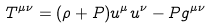Convert formula to latex. <formula><loc_0><loc_0><loc_500><loc_500>T ^ { \mu \nu } = ( \rho + P ) u ^ { \mu } u ^ { \nu } - P g ^ { \mu \nu }</formula> 